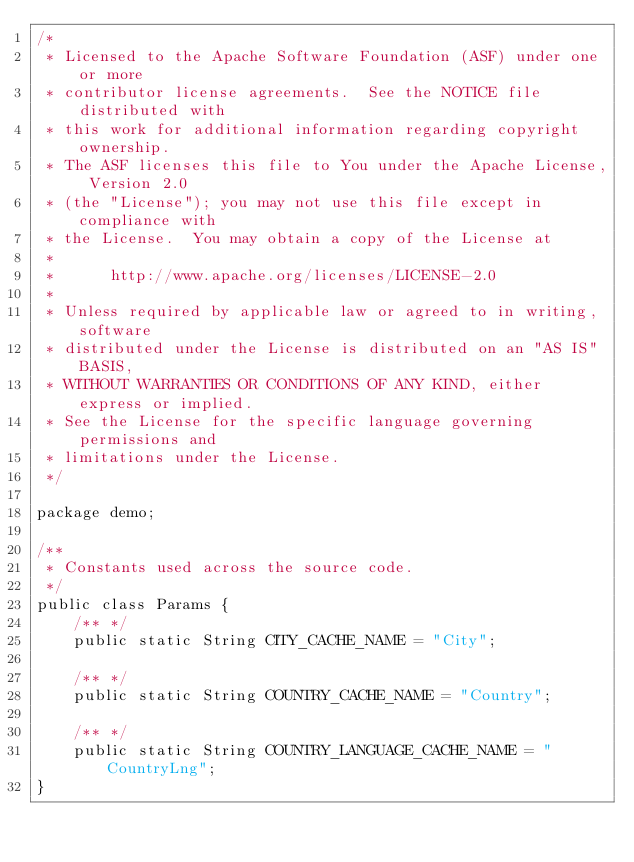Convert code to text. <code><loc_0><loc_0><loc_500><loc_500><_Java_>/*
 * Licensed to the Apache Software Foundation (ASF) under one or more
 * contributor license agreements.  See the NOTICE file distributed with
 * this work for additional information regarding copyright ownership.
 * The ASF licenses this file to You under the Apache License, Version 2.0
 * (the "License"); you may not use this file except in compliance with
 * the License.  You may obtain a copy of the License at
 *
 *      http://www.apache.org/licenses/LICENSE-2.0
 *
 * Unless required by applicable law or agreed to in writing, software
 * distributed under the License is distributed on an "AS IS" BASIS,
 * WITHOUT WARRANTIES OR CONDITIONS OF ANY KIND, either express or implied.
 * See the License for the specific language governing permissions and
 * limitations under the License.
 */

package demo;

/**
 * Constants used across the source code.
 */
public class Params {
    /** */
    public static String CITY_CACHE_NAME = "City";

    /** */
    public static String COUNTRY_CACHE_NAME = "Country";

    /** */
    public static String COUNTRY_LANGUAGE_CACHE_NAME = "CountryLng";
}
</code> 